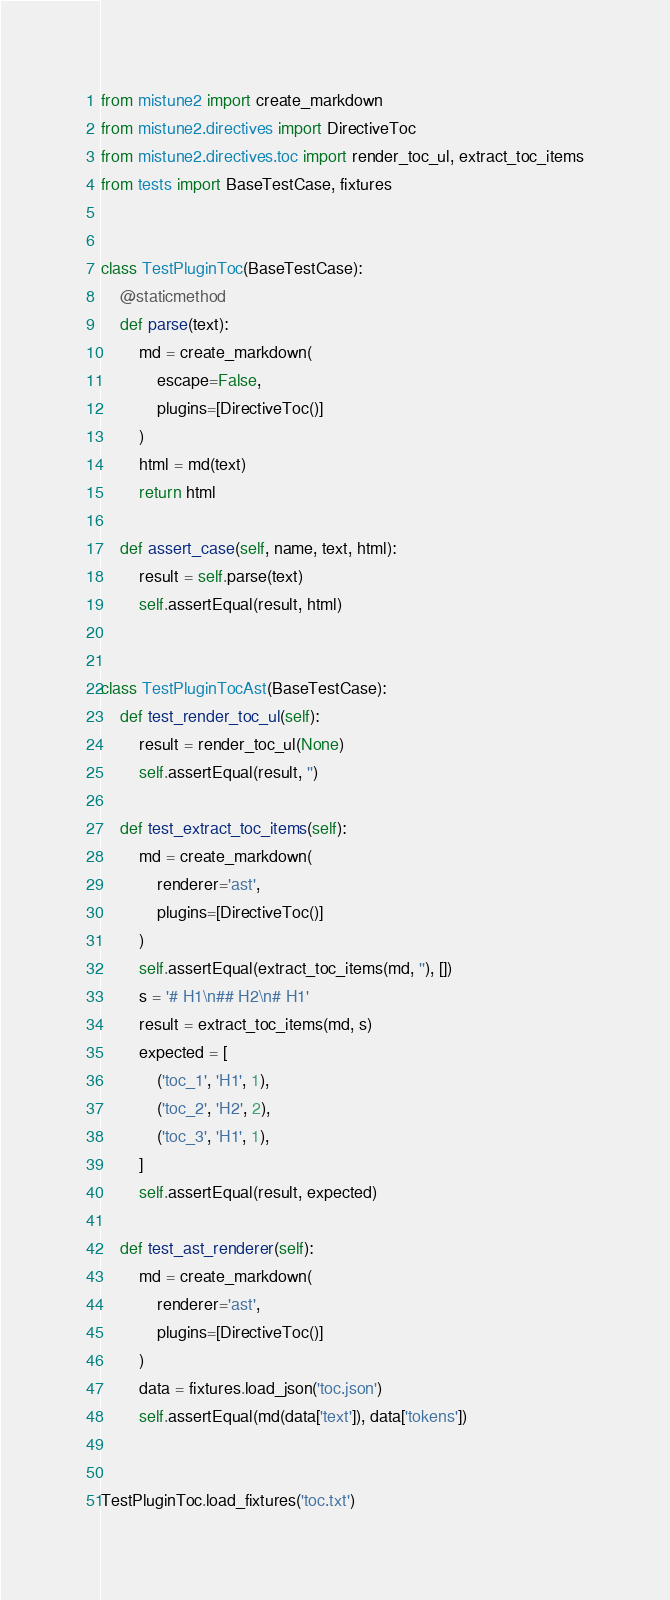<code> <loc_0><loc_0><loc_500><loc_500><_Python_>from mistune2 import create_markdown
from mistune2.directives import DirectiveToc
from mistune2.directives.toc import render_toc_ul, extract_toc_items
from tests import BaseTestCase, fixtures


class TestPluginToc(BaseTestCase):
    @staticmethod
    def parse(text):
        md = create_markdown(
            escape=False,
            plugins=[DirectiveToc()]
        )
        html = md(text)
        return html

    def assert_case(self, name, text, html):
        result = self.parse(text)
        self.assertEqual(result, html)


class TestPluginTocAst(BaseTestCase):
    def test_render_toc_ul(self):
        result = render_toc_ul(None)
        self.assertEqual(result, '')

    def test_extract_toc_items(self):
        md = create_markdown(
            renderer='ast',
            plugins=[DirectiveToc()]
        )
        self.assertEqual(extract_toc_items(md, ''), [])
        s = '# H1\n## H2\n# H1'
        result = extract_toc_items(md, s)
        expected = [
            ('toc_1', 'H1', 1),
            ('toc_2', 'H2', 2),
            ('toc_3', 'H1', 1),
        ]
        self.assertEqual(result, expected)

    def test_ast_renderer(self):
        md = create_markdown(
            renderer='ast',
            plugins=[DirectiveToc()]
        )
        data = fixtures.load_json('toc.json')
        self.assertEqual(md(data['text']), data['tokens'])


TestPluginToc.load_fixtures('toc.txt')
</code> 